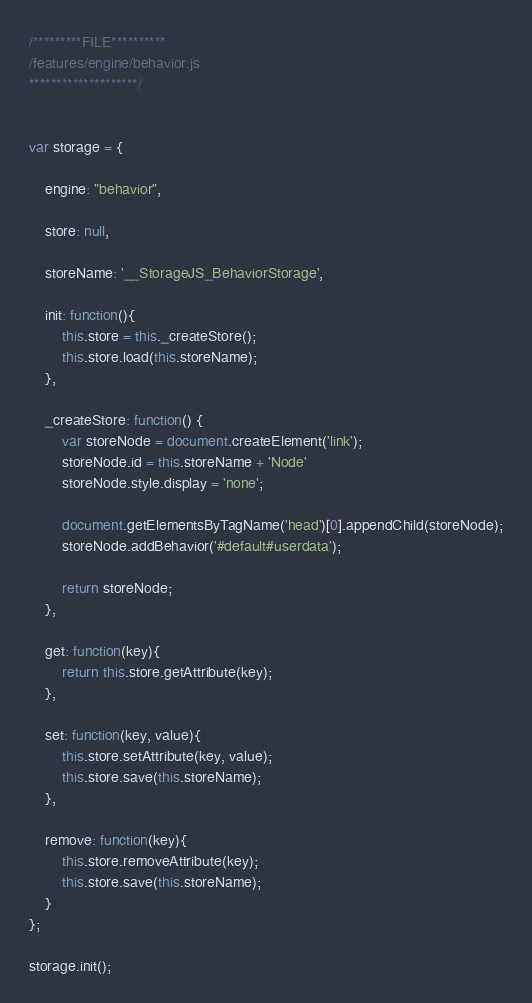<code> <loc_0><loc_0><loc_500><loc_500><_JavaScript_>/*********FILE**********
/features/engine/behavior.js
********************/


var storage = {
		
	engine: "behavior",
	
	store: null,
	
	storeName: '__StorageJS_BehaviorStorage',
	
	init: function(){
		this.store = this._createStore();
		this.store.load(this.storeName);
	},
	
	_createStore: function() {
        var storeNode = document.createElement('link');
        storeNode.id = this.storeName + 'Node'
        storeNode.style.display = 'none';
        
        document.getElementsByTagName('head')[0].appendChild(storeNode);
        storeNode.addBehavior('#default#userdata');
        
        return storeNode;
	},
	
	get: function(key){
		return this.store.getAttribute(key);
	},
	
	set: function(key, value){
		this.store.setAttribute(key, value);
		this.store.save(this.storeName);
	},
	
	remove: function(key){
		this.store.removeAttribute(key);
		this.store.save(this.storeName);
	}
};

storage.init();
</code> 